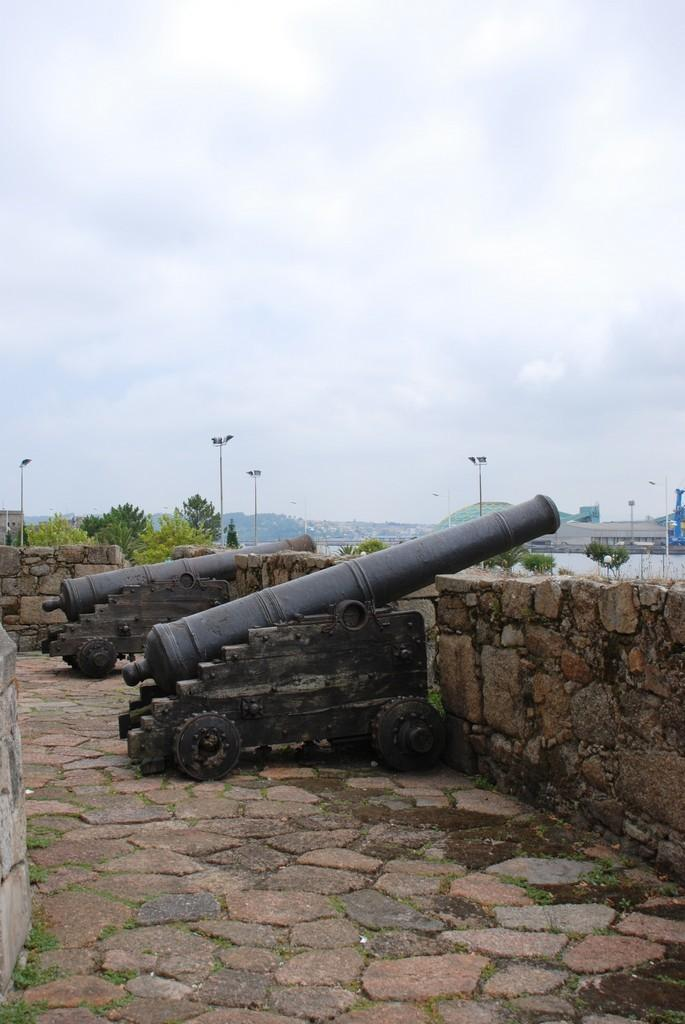What objects are present in the image that resemble weapons? There are two cannons in the image. What type of surface are the cannons placed on? The cannons are placed on cobbler stones. What is the closest structure to the cannons in the image? There is a small boundary wall in the front of the image. What can be seen in the distance in the image? Trees and electrical poles are visible in the background of the image. What type of map is visible in the image? There is no map present in the image. What type of building is visible in the image? There is no building visible in the image; only a small boundary wall and the cannons are present. 